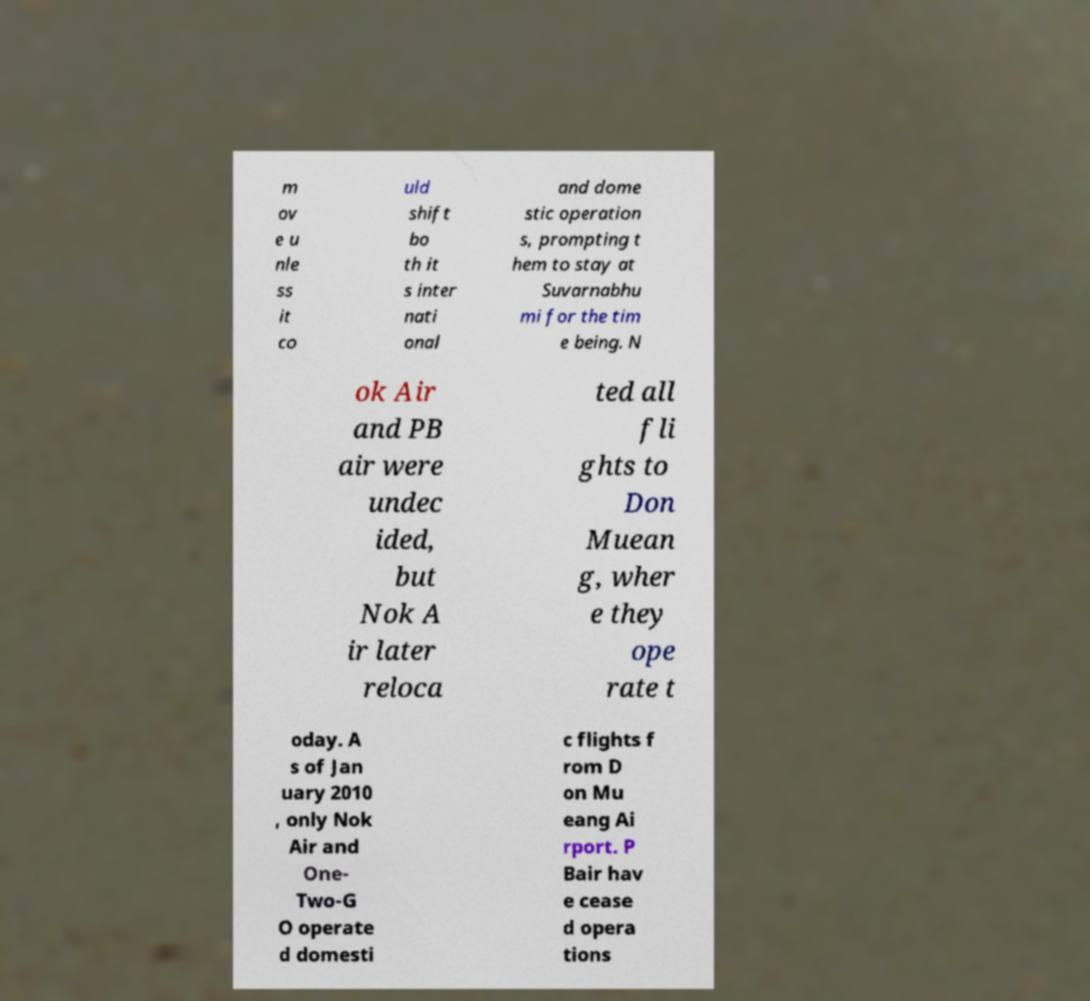Please identify and transcribe the text found in this image. m ov e u nle ss it co uld shift bo th it s inter nati onal and dome stic operation s, prompting t hem to stay at Suvarnabhu mi for the tim e being. N ok Air and PB air were undec ided, but Nok A ir later reloca ted all fli ghts to Don Muean g, wher e they ope rate t oday. A s of Jan uary 2010 , only Nok Air and One- Two-G O operate d domesti c flights f rom D on Mu eang Ai rport. P Bair hav e cease d opera tions 